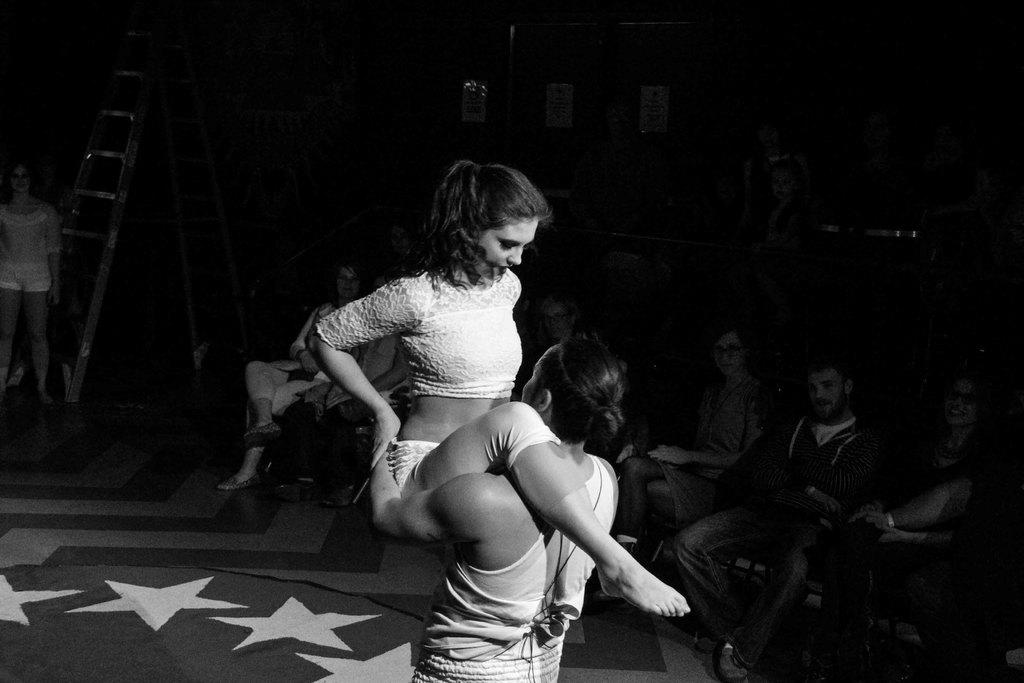What is the color scheme of the image? The image is black and white. Who are the people in the image? There is a man and a woman in the image. What are the man and woman doing in the image? The man and woman are dancing on a stage. What can be seen in the background of the image? There are many people sitting on chairs in the background. How are the people in the background reacting to the dancing couple? The people in the background are staring at the dancing couple. What type of laborer is working on the wax sculpture in the image? There is no laborer or wax sculpture present in the image. What kind of show is the dancing couple performing in the image? The image does not provide information about the type of show the dancing couple is performing. 